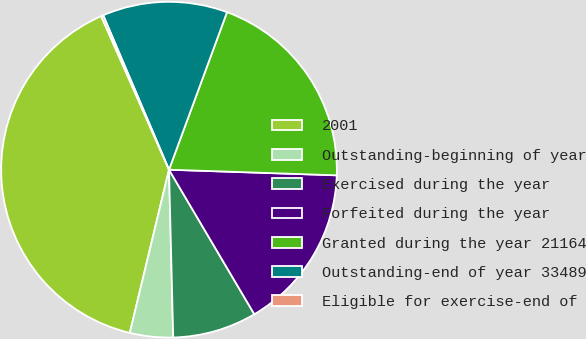Convert chart. <chart><loc_0><loc_0><loc_500><loc_500><pie_chart><fcel>2001<fcel>Outstanding-beginning of year<fcel>Exercised during the year<fcel>Forfeited during the year<fcel>Granted during the year 21164<fcel>Outstanding-end of year 33489<fcel>Eligible for exercise-end of<nl><fcel>39.63%<fcel>4.15%<fcel>8.09%<fcel>15.98%<fcel>19.92%<fcel>12.03%<fcel>0.21%<nl></chart> 